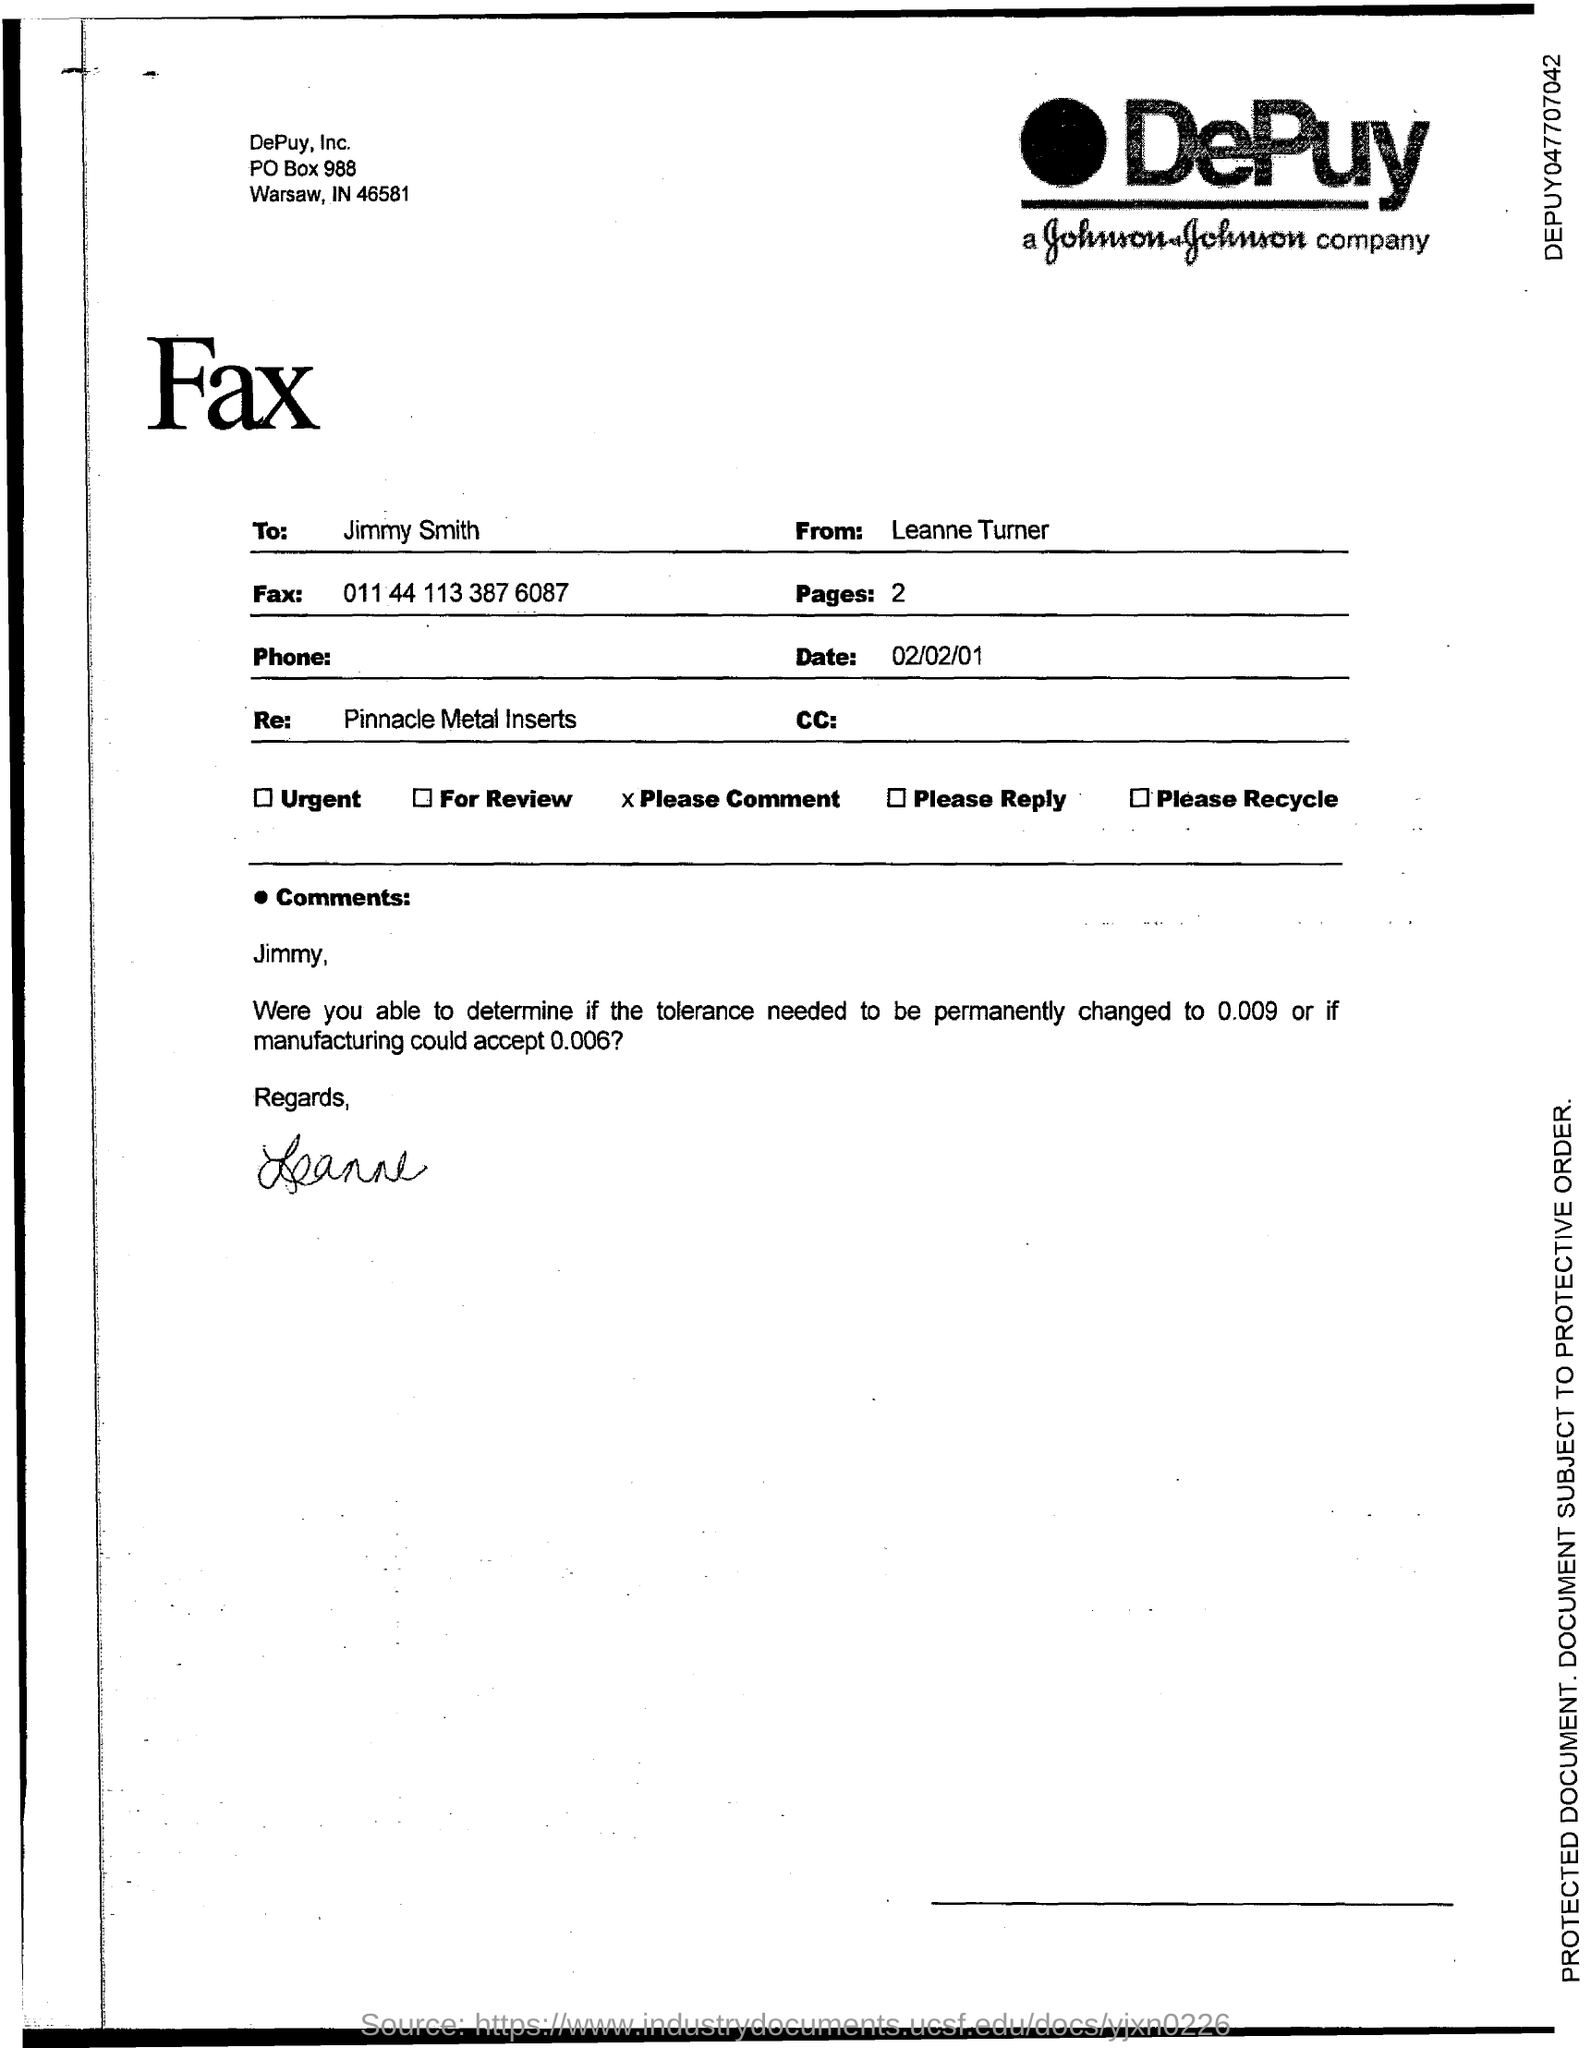What is the po box no. of depuy, inc?
Keep it short and to the point. 988. What is the number of pages?
Give a very brief answer. 2. What is the fax number ?
Provide a short and direct response. 011 44 113 387 6087. In which state is depuy, inc located?
Provide a succinct answer. IN. 